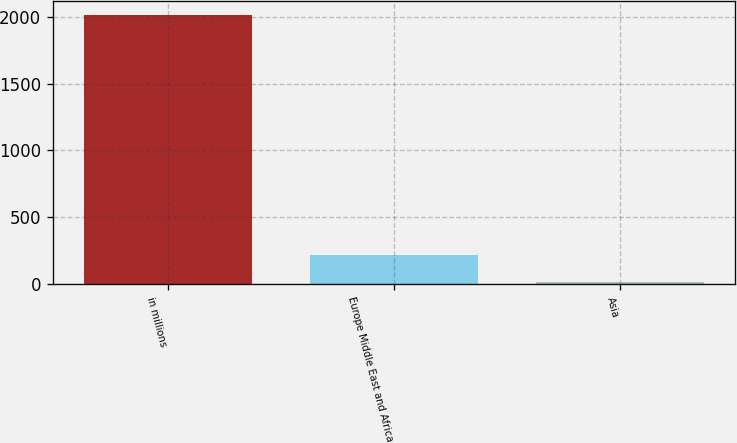<chart> <loc_0><loc_0><loc_500><loc_500><bar_chart><fcel>in millions<fcel>Europe Middle East and Africa<fcel>Asia<nl><fcel>2016<fcel>214.2<fcel>14<nl></chart> 